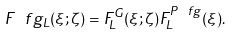Convert formula to latex. <formula><loc_0><loc_0><loc_500><loc_500>F ^ { \ } f g _ { L } ( \xi ; \zeta ) = F _ { L } ^ { G } ( \xi ; \zeta ) F _ { L } ^ { P \ f g } ( \xi ) .</formula> 